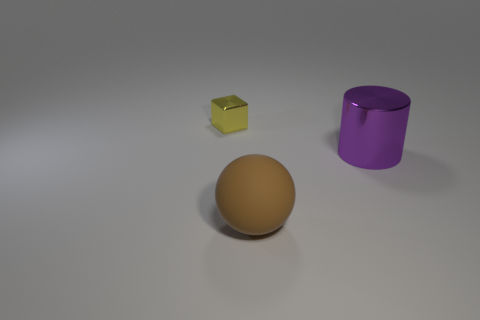Are there any other things that have the same size as the cube?
Make the answer very short. No. Are there any other things that have the same shape as the brown matte thing?
Your answer should be very brief. No. There is a large object that is in front of the large thing behind the rubber sphere; what number of big objects are behind it?
Offer a very short reply. 1. Are there more purple metal things than large green things?
Keep it short and to the point. Yes. Does the brown object have the same size as the metallic block?
Provide a succinct answer. No. How many objects are big metallic cylinders or brown matte cubes?
Your answer should be compact. 1. What is the shape of the metal object that is in front of the tiny yellow thing that is to the left of the metal thing on the right side of the tiny yellow object?
Provide a succinct answer. Cylinder. Is the material of the cylinder behind the brown matte thing the same as the object behind the purple shiny cylinder?
Your answer should be very brief. Yes. Are there fewer big rubber things that are right of the big purple metallic object than cylinders in front of the yellow object?
Provide a short and direct response. Yes. How many other things are there of the same shape as the yellow thing?
Your response must be concise. 0. 